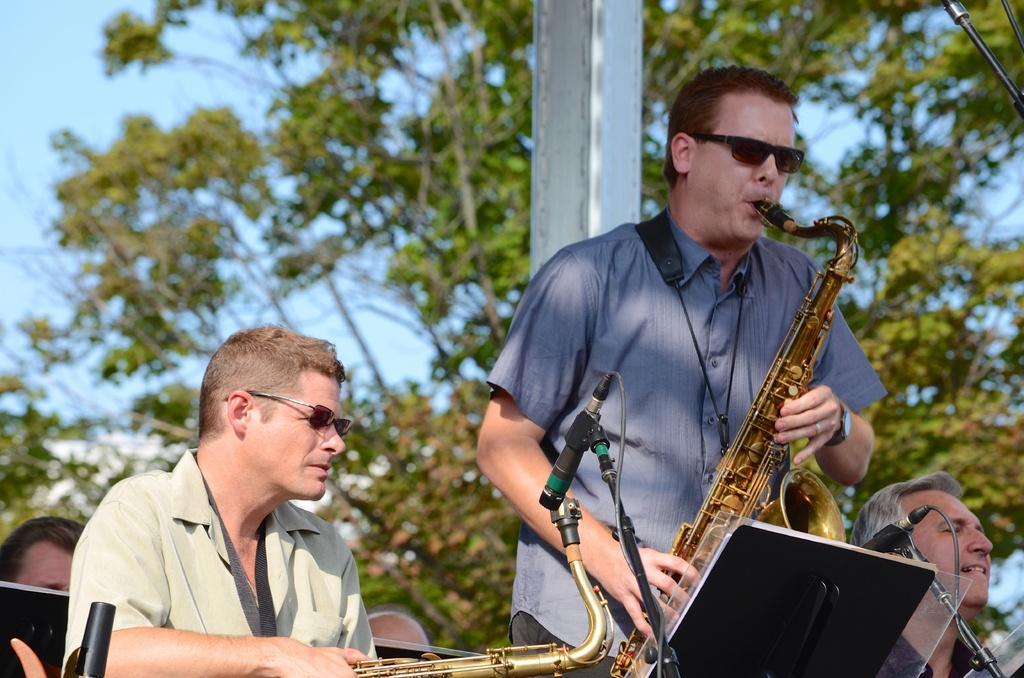In one or two sentences, can you explain what this image depicts? On the right side a man standing and playing a musical instrument. Beside this man few persons are sitting. In front of this man there are two mic stands and a black color object. In the background, I can see a pole and trees. At the top I can see the sky. 